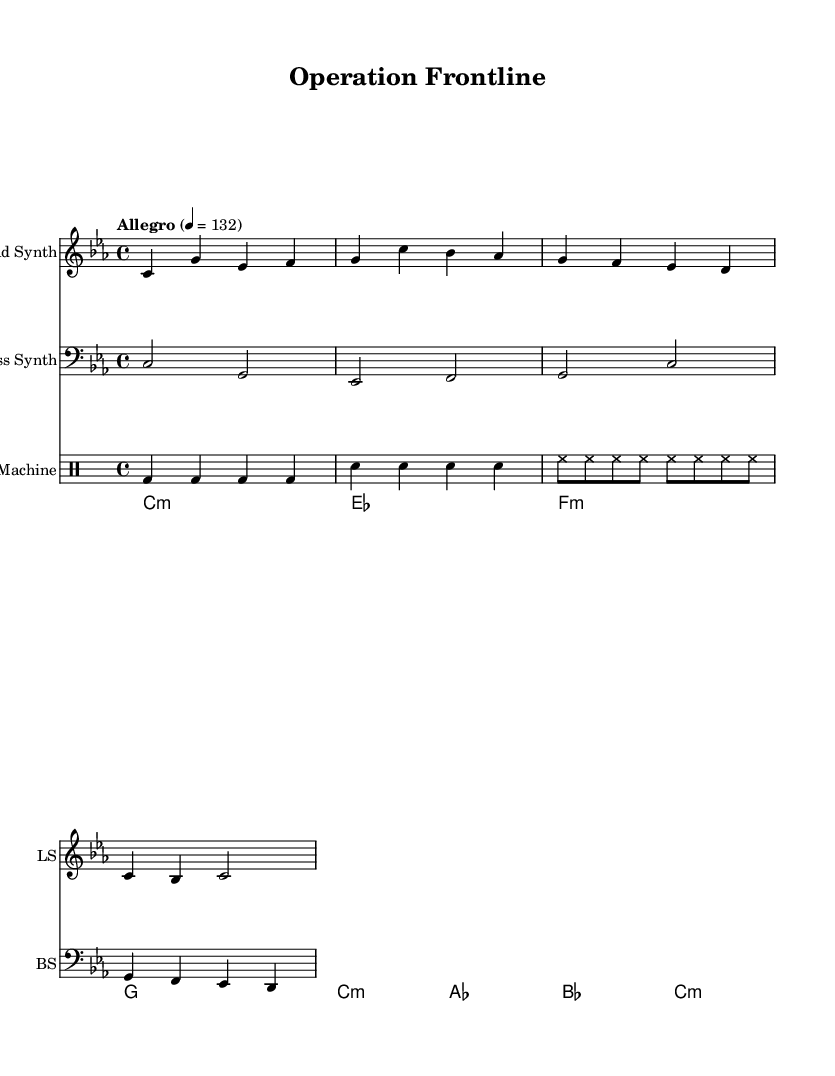What is the key signature of this music? The music has a key signature of C minor, which contains three flats: B♭, E♭, and A♭. This is indicated in the music where the key is stated at the beginning as "c" represented in lowercase.
Answer: C minor What is the time signature of this music? The time signature is set at the beginning of the score as 4/4, which means there are four beats in each measure and a quarter note receives one beat. This can be identified clearly noted on the first line of the score.
Answer: 4/4 What is the tempo marking indicated in this music? The tempo marking is labeled as "Allegro" with a tempo of 132 beats per minute, which signifies that the music should be played fast and lively. This is stated above the first measure in the score.
Answer: Allegro, 132 How many measures are present in the lead synth part? The lead synth part contains a total of 4 measures, as indicated by counting each group of notes separated by the vertical lines on the music sheet. Each group represents a measure.
Answer: 4 What is the type of the last chord in the pad synth section? The last chord in the pad synth section is labeled as "c:m," which denotes a C minor chord, visually seen at the end of the chord progression at the last measure for pad synth.
Answer: C minor Which drum sounds are repeated in the drum machine section? The drum machine section features a repeated bass drum sound (bd) and snare drum sound (sn) followed by hi-hat sounds (hh), as observed in their respective time notations across the measures.
Answer: Bass drum, snare drum, hi-hat 